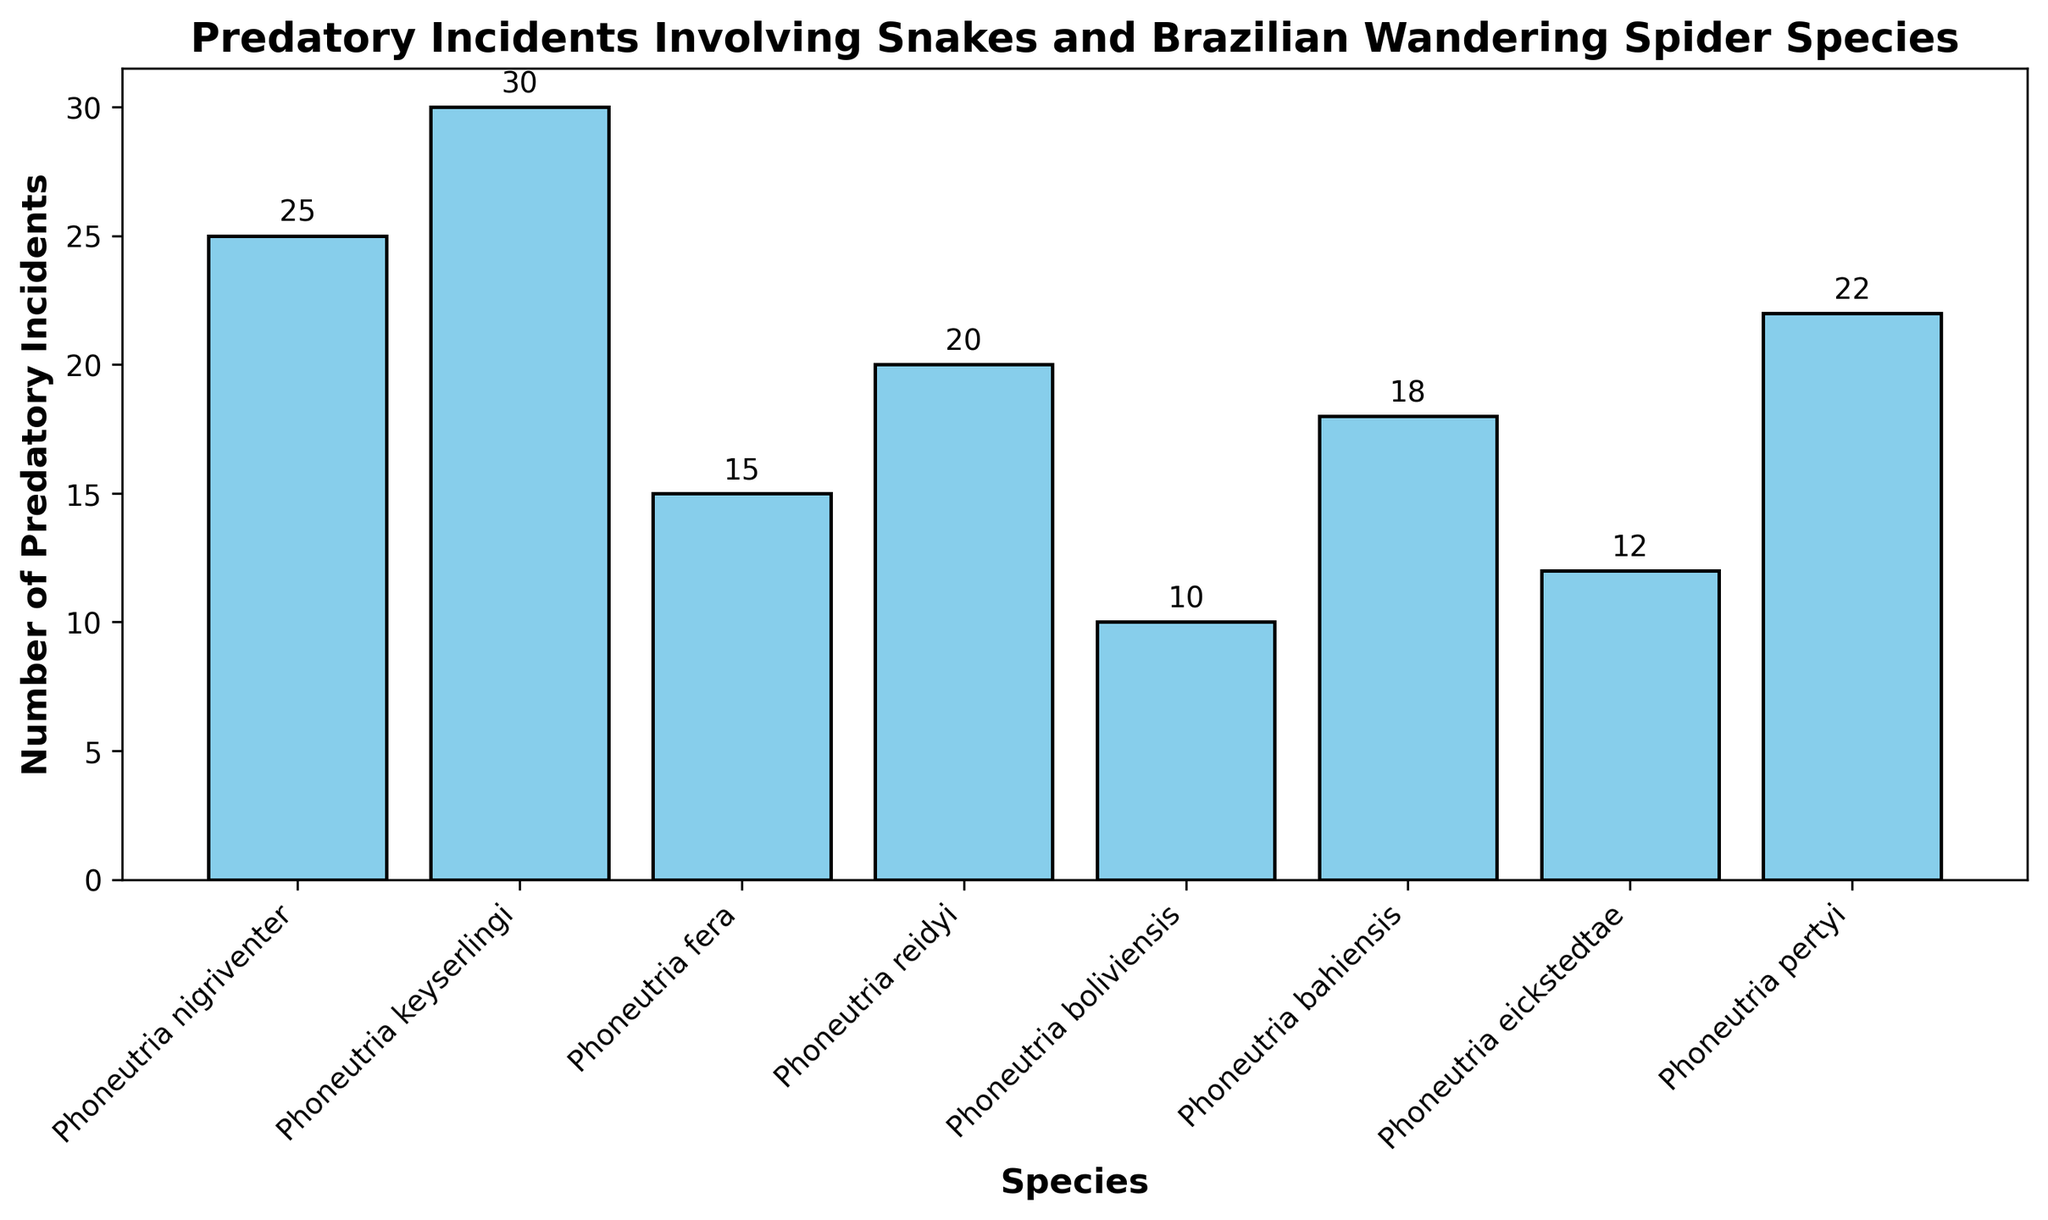Which species has the highest number of predatory incidents? Look at the chart and identify the species represented by the tallest bar. The species with the highest number of predatory incidents is the one with the tallest bar.
Answer: Phoneutria keyserlingi Which species has the lowest number of predatory incidents? Identify the species represented by the shortest bar in the chart. The species with the lowest number of predatory incidents is the one with the shortest bar.
Answer: Phoneutria boliviensis What is the total number of predatory incidents for all species combined? To find the total number of predatory incidents, sum the heights of all bars. Add the values: 25 + 30 + 15 + 20 + 10 + 18 + 12 + 22.
Answer: 152 Which two species have a combined total of 50 predatory incidents? Look at the chart and identify pairs of species whose combined bar heights equal 50. Phoneutria keyserlingi (30) and Phoneutria boliviensis (10) sum to 40, and Phoneutria nigriventer (25) and Phoneutria reidyi (20) sum to 45. The pairs should be checked until reaching the correct total.
Answer: Phoneutria keyserlingi and Phoneutria fera How many more predatory incidents does Phoneutria keyserlingi have compared to Phoneutria boliviensis? Subtract the height of the bar representing Phoneutria boliviensis from the height of the bar representing Phoneutria keyserlingi. Calculation: 30 - 10.
Answer: 20 Is the number of predatory incidents for Phoneutria reidyi greater than the number for Phoneutria bahiensis? Compare the heights of the bars representing Phoneutria reidyi and Phoneutria bahiensis. The height of the bar representing Phoneutria reidyi (20) should be compared with that of Phoneutria bahiensis (18).
Answer: Yes What is the average number of predatory incidents across all species? Sum all the heights of the bars and divide by the number of species. Calculation: (25 + 30 + 15 + 20 + 10 + 18 + 12 + 22)/8.
Answer: 19 Which species have a number of predatory incidents within the range of 10 to 20? Identify the bars falling within the given range. The species represented by bars whose heights are between 10 and 20 are Phoneutria fera (15), Phoneutria reidyi (20), Phoneutria boliviensis (10), Phoneutria bahiensis (18), and Phoneutria eickstedtae (12).
Answer: Phoneutria fera, Phoneutria reidyi, Phoneutria boliviensis, Phoneutria bahiensis, Phoneutria eickstedtae What percentage of the total number of predatory incidents is attributed to Phoneutria nigriventer? Find the proportion of the total number of predatory incidents that belongs to Phoneutria nigriventer and multiply by 100. Calculation: (25/152) * 100.
Answer: 16.45% What is the difference in the number of predatory incidents between the species with the highest and lowest values? Subtract the height of the bar representing Phoneutria boliviensis (lowest) from the height of the bar representing Phoneutria keyserlingi (highest). Calculation: 30 - 10.
Answer: 20 